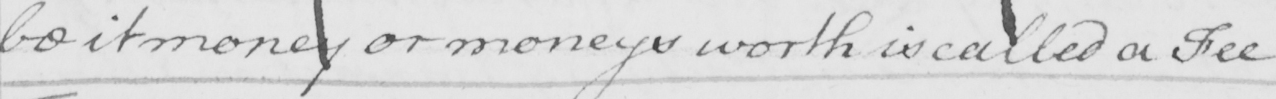Transcribe the text shown in this historical manuscript line. be it money or moneys worth is called a Fee . 